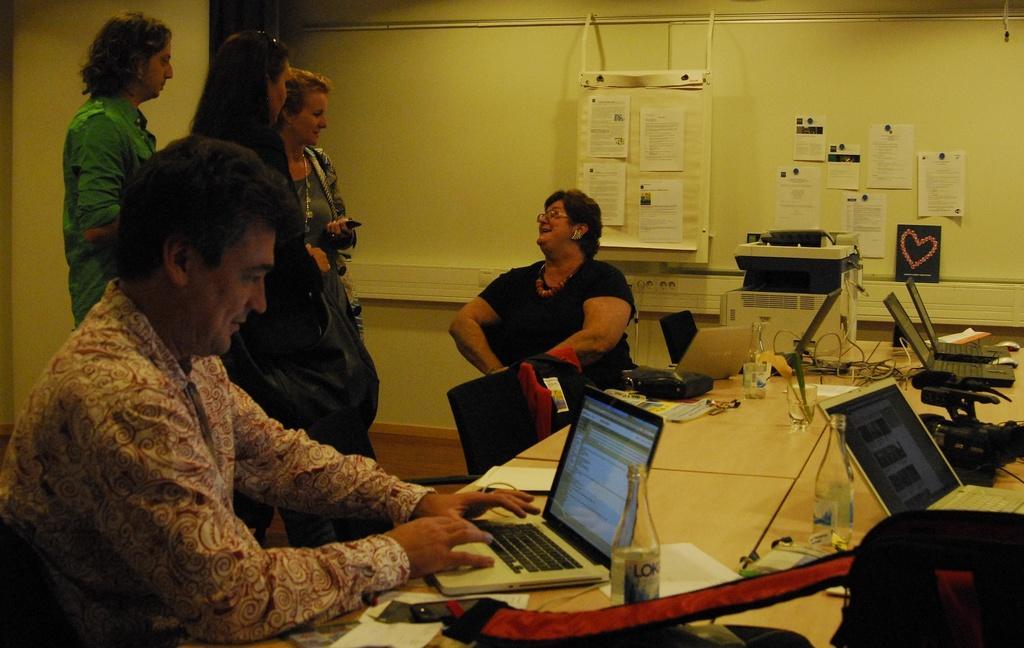Can you describe this image briefly? In this image, we can see few people. Few are sitting and standing. Here there is a desk. Few laptops, some objects are placed on it. Here we can see chair. Background there is a wallboard, few posters and machine. 